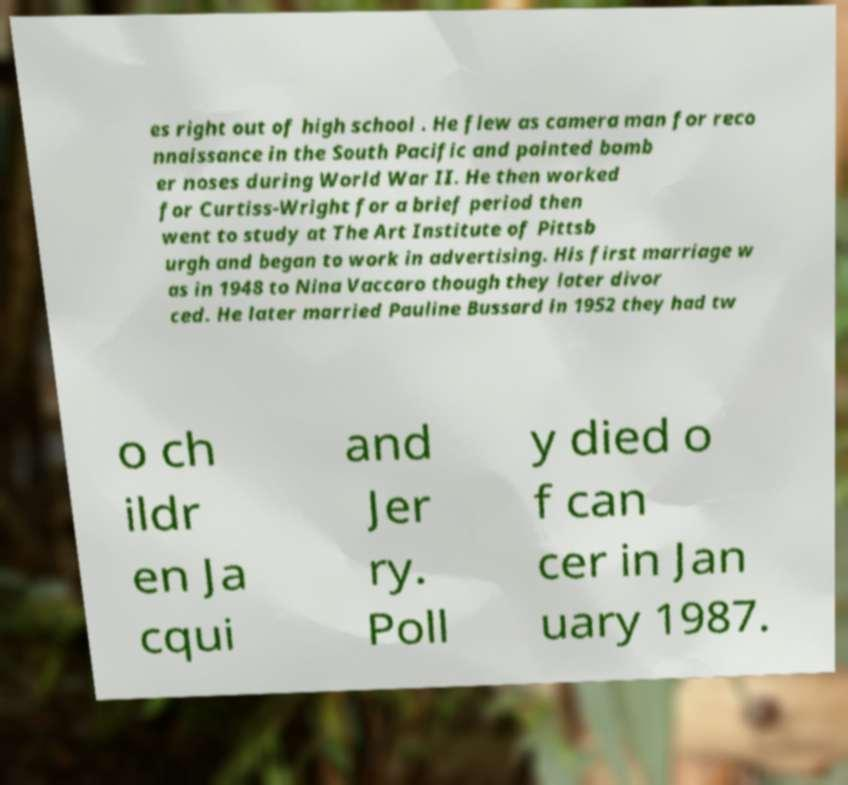Could you assist in decoding the text presented in this image and type it out clearly? es right out of high school . He flew as camera man for reco nnaissance in the South Pacific and painted bomb er noses during World War II. He then worked for Curtiss-Wright for a brief period then went to study at The Art Institute of Pittsb urgh and began to work in advertising. His first marriage w as in 1948 to Nina Vaccaro though they later divor ced. He later married Pauline Bussard in 1952 they had tw o ch ildr en Ja cqui and Jer ry. Poll y died o f can cer in Jan uary 1987. 